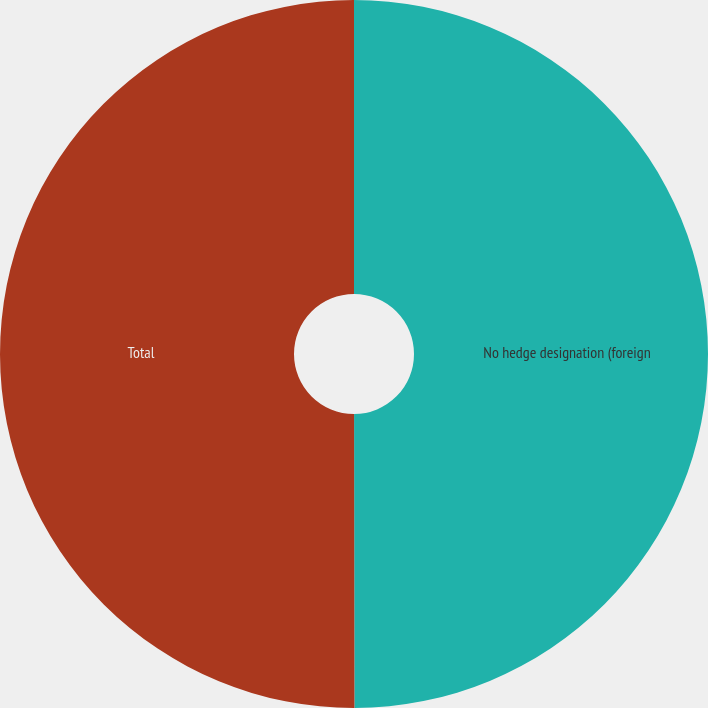Convert chart. <chart><loc_0><loc_0><loc_500><loc_500><pie_chart><fcel>No hedge designation (foreign<fcel>Total<nl><fcel>49.98%<fcel>50.02%<nl></chart> 